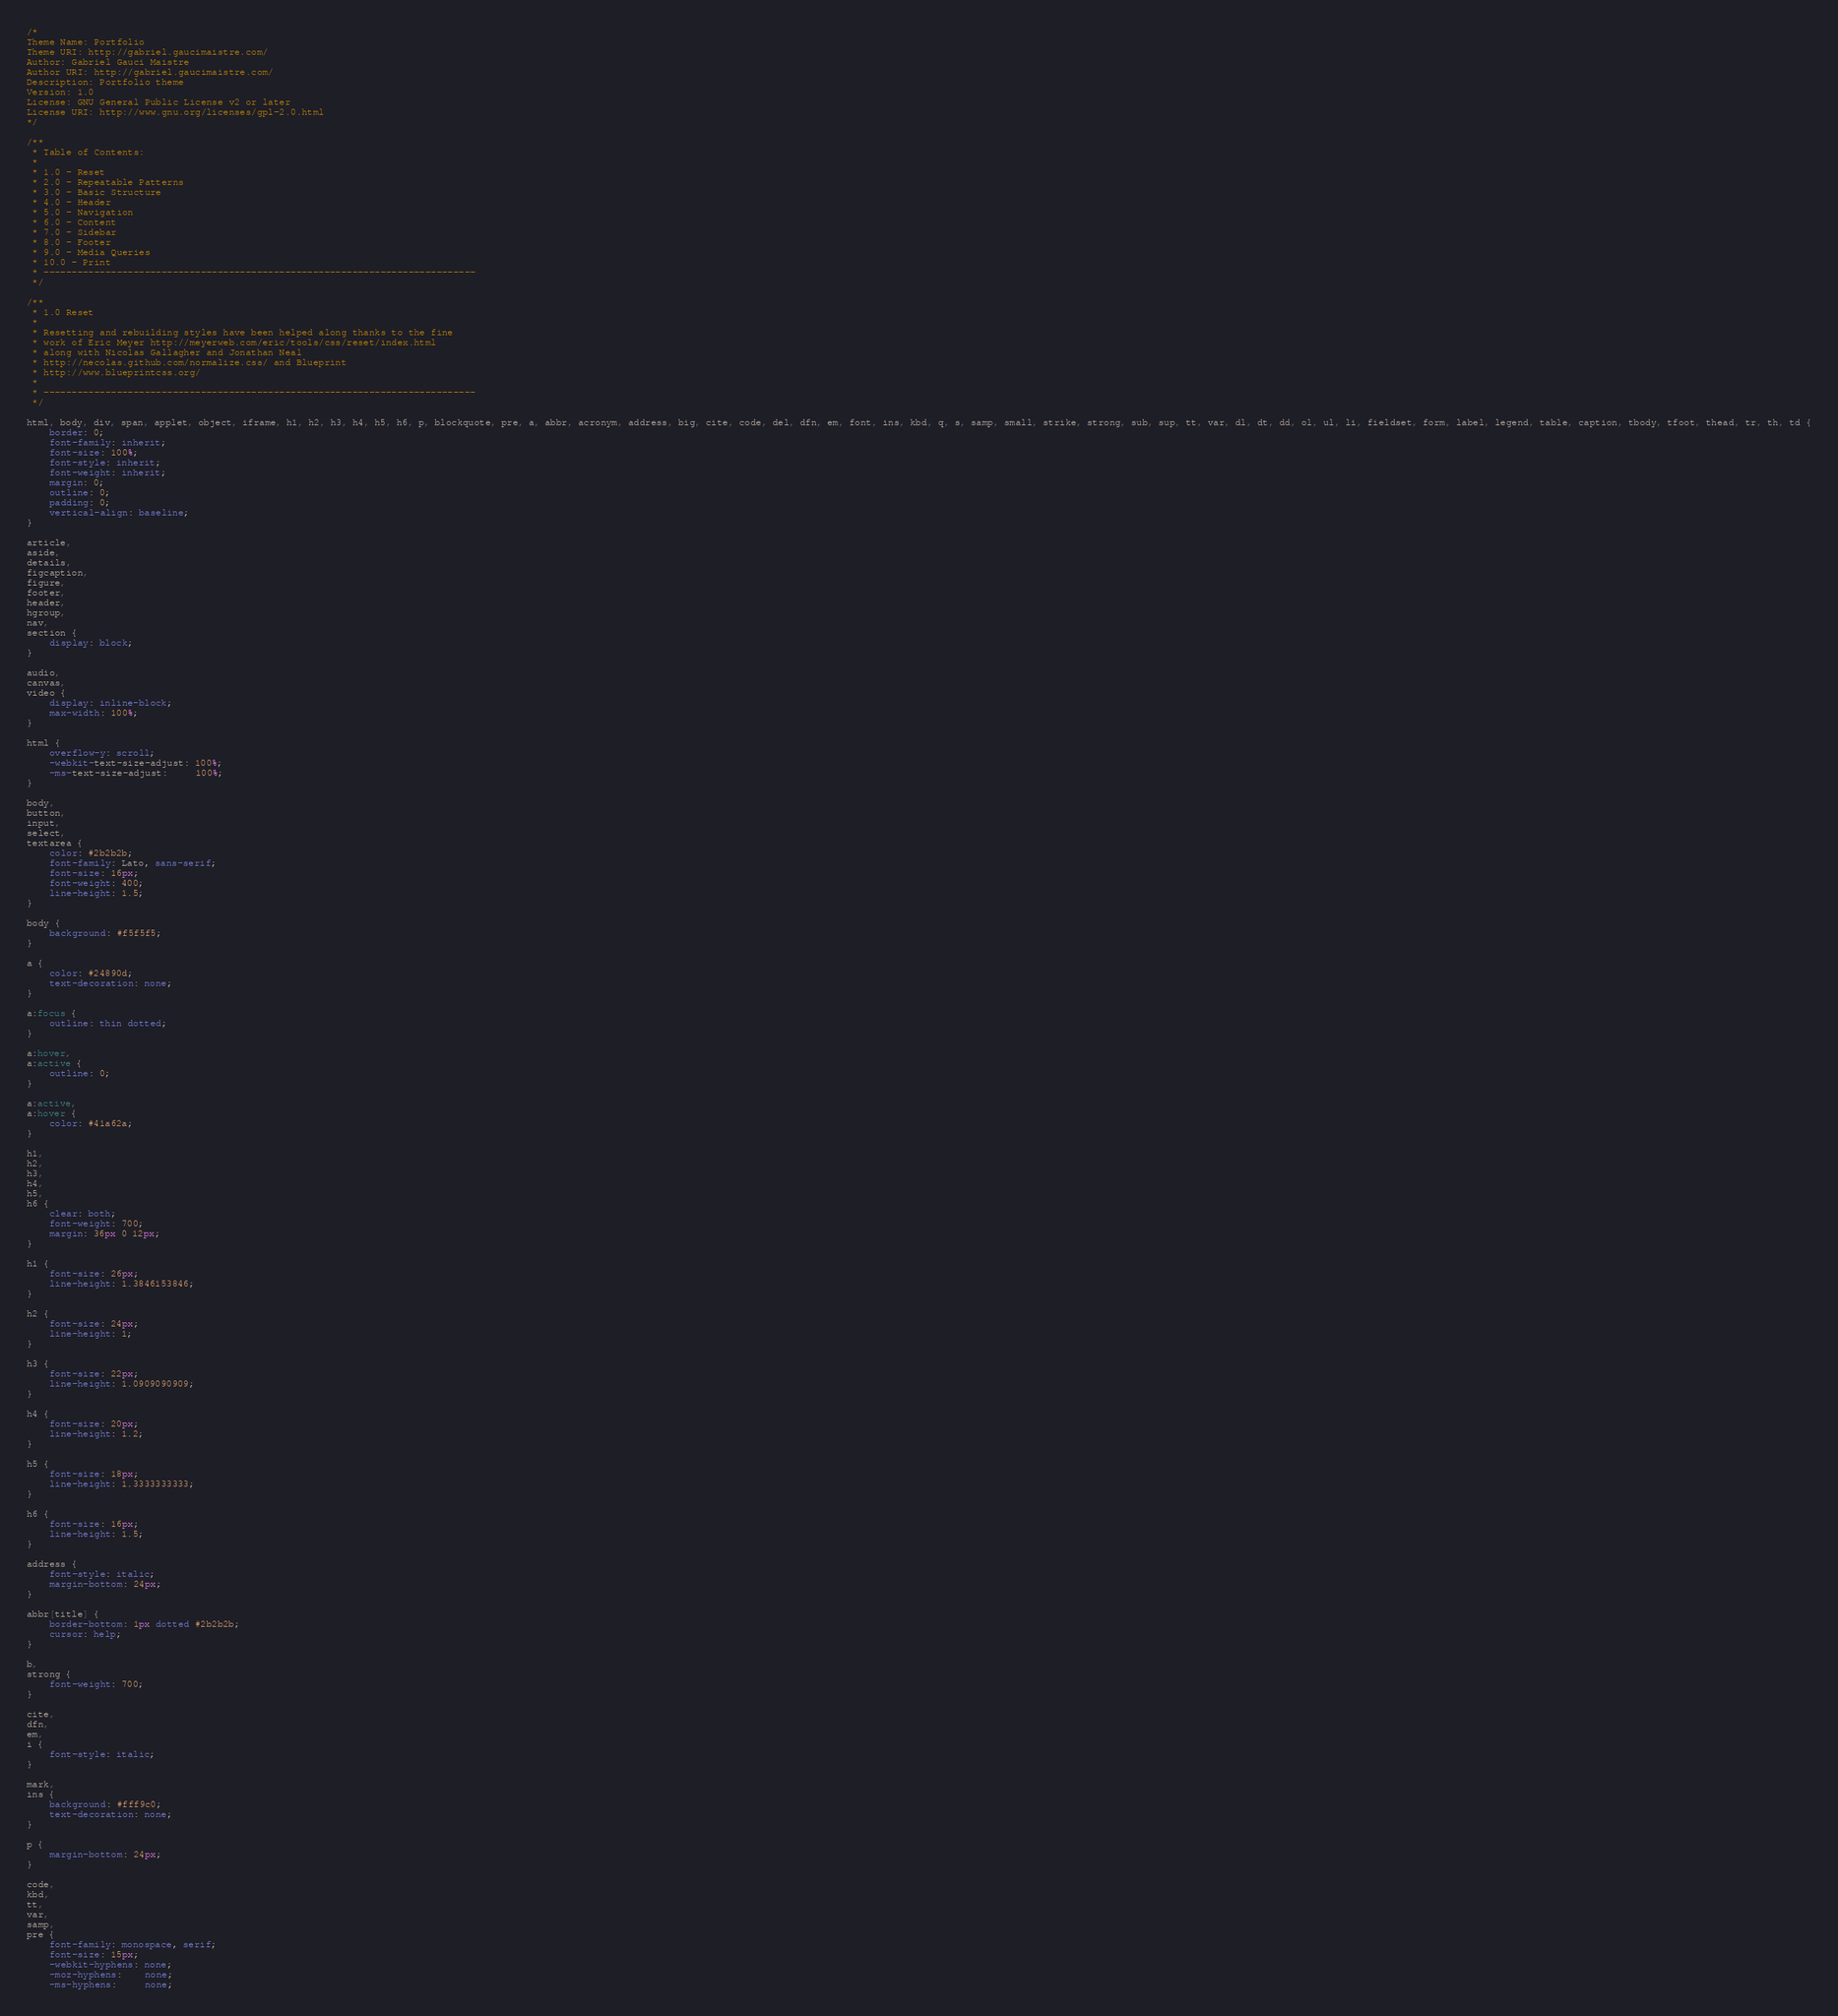Convert code to text. <code><loc_0><loc_0><loc_500><loc_500><_CSS_>/*
Theme Name: Portfolio
Theme URI: http://gabriel.gaucimaistre.com/
Author: Gabriel Gauci Maistre
Author URI: http://gabriel.gaucimaistre.com/
Description: Portfolio theme
Version: 1.0
License: GNU General Public License v2 or later
License URI: http://www.gnu.org/licenses/gpl-2.0.html
*/

/**
 * Table of Contents:
 *
 * 1.0 - Reset
 * 2.0 - Repeatable Patterns
 * 3.0 - Basic Structure
 * 4.0 - Header
 * 5.0 - Navigation
 * 6.0 - Content
 * 7.0 - Sidebar
 * 8.0 - Footer
 * 9.0 - Media Queries
 * 10.0 - Print
 * -----------------------------------------------------------------------------
 */

/**
 * 1.0 Reset
 *
 * Resetting and rebuilding styles have been helped along thanks to the fine
 * work of Eric Meyer http://meyerweb.com/eric/tools/css/reset/index.html
 * along with Nicolas Gallagher and Jonathan Neal
 * http://necolas.github.com/normalize.css/ and Blueprint
 * http://www.blueprintcss.org/
 *
 * -----------------------------------------------------------------------------
 */

html, body, div, span, applet, object, iframe, h1, h2, h3, h4, h5, h6, p, blockquote, pre, a, abbr, acronym, address, big, cite, code, del, dfn, em, font, ins, kbd, q, s, samp, small, strike, strong, sub, sup, tt, var, dl, dt, dd, ol, ul, li, fieldset, form, label, legend, table, caption, tbody, tfoot, thead, tr, th, td {
	border: 0;
	font-family: inherit;
	font-size: 100%;
	font-style: inherit;
	font-weight: inherit;
	margin: 0;
	outline: 0;
	padding: 0;
	vertical-align: baseline;
}

article,
aside,
details,
figcaption,
figure,
footer,
header,
hgroup,
nav,
section {
	display: block;
}

audio,
canvas,
video {
	display: inline-block;
	max-width: 100%;
}

html {
	overflow-y: scroll;
	-webkit-text-size-adjust: 100%;
	-ms-text-size-adjust:     100%;
}

body,
button,
input,
select,
textarea {
	color: #2b2b2b;
	font-family: Lato, sans-serif;
	font-size: 16px;
	font-weight: 400;
	line-height: 1.5;
}

body {
	background: #f5f5f5;
}

a {
	color: #24890d;
	text-decoration: none;
}

a:focus {
	outline: thin dotted;
}

a:hover,
a:active {
	outline: 0;
}

a:active,
a:hover {
	color: #41a62a;
}

h1,
h2,
h3,
h4,
h5,
h6 {
	clear: both;
	font-weight: 700;
	margin: 36px 0 12px;
}

h1 {
	font-size: 26px;
	line-height: 1.3846153846;
}

h2 {
	font-size: 24px;
	line-height: 1;
}

h3 {
	font-size: 22px;
	line-height: 1.0909090909;
}

h4 {
	font-size: 20px;
	line-height: 1.2;
}

h5 {
	font-size: 18px;
	line-height: 1.3333333333;
}

h6 {
	font-size: 16px;
	line-height: 1.5;
}

address {
	font-style: italic;
	margin-bottom: 24px;
}

abbr[title] {
	border-bottom: 1px dotted #2b2b2b;
	cursor: help;
}

b,
strong {
	font-weight: 700;
}

cite,
dfn,
em,
i {
	font-style: italic;
}

mark,
ins {
	background: #fff9c0;
	text-decoration: none;
}

p {
	margin-bottom: 24px;
}

code,
kbd,
tt,
var,
samp,
pre {
	font-family: monospace, serif;
	font-size: 15px;
	-webkit-hyphens: none;
	-moz-hyphens:    none;
	-ms-hyphens:     none;</code> 